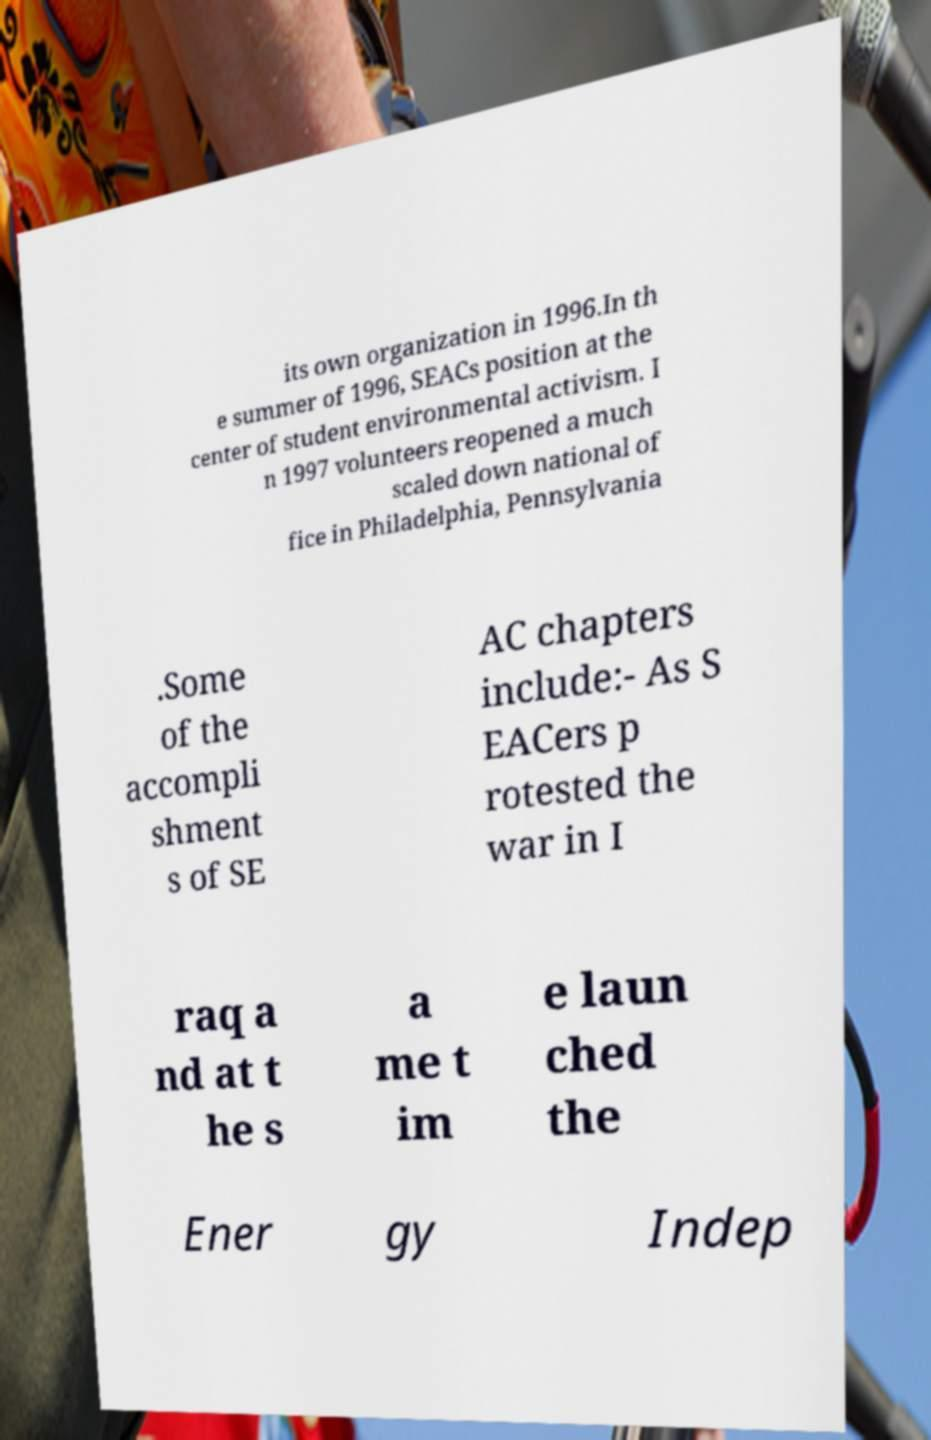Could you extract and type out the text from this image? its own organization in 1996.In th e summer of 1996, SEACs position at the center of student environmental activism. I n 1997 volunteers reopened a much scaled down national of fice in Philadelphia, Pennsylvania .Some of the accompli shment s of SE AC chapters include:- As S EACers p rotested the war in I raq a nd at t he s a me t im e laun ched the Ener gy Indep 